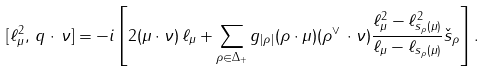Convert formula to latex. <formula><loc_0><loc_0><loc_500><loc_500>[ \ell ^ { 2 } _ { \mu } , \, q \cdot \, \nu ] = - i \left [ 2 ( \mu \cdot \nu ) \, \ell _ { \mu } + \sum _ { \rho \in \Delta _ { + } } g _ { | \rho | } ( \rho \cdot \mu ) ( \rho ^ { \vee } \, \cdot \nu ) \frac { \ell _ { \mu } ^ { 2 } - \ell ^ { 2 } _ { s _ { \rho } ( \mu ) } } { \ell _ { \mu } - \ell _ { s _ { \rho } ( \mu ) } } \check { s } _ { \rho } \right ] .</formula> 